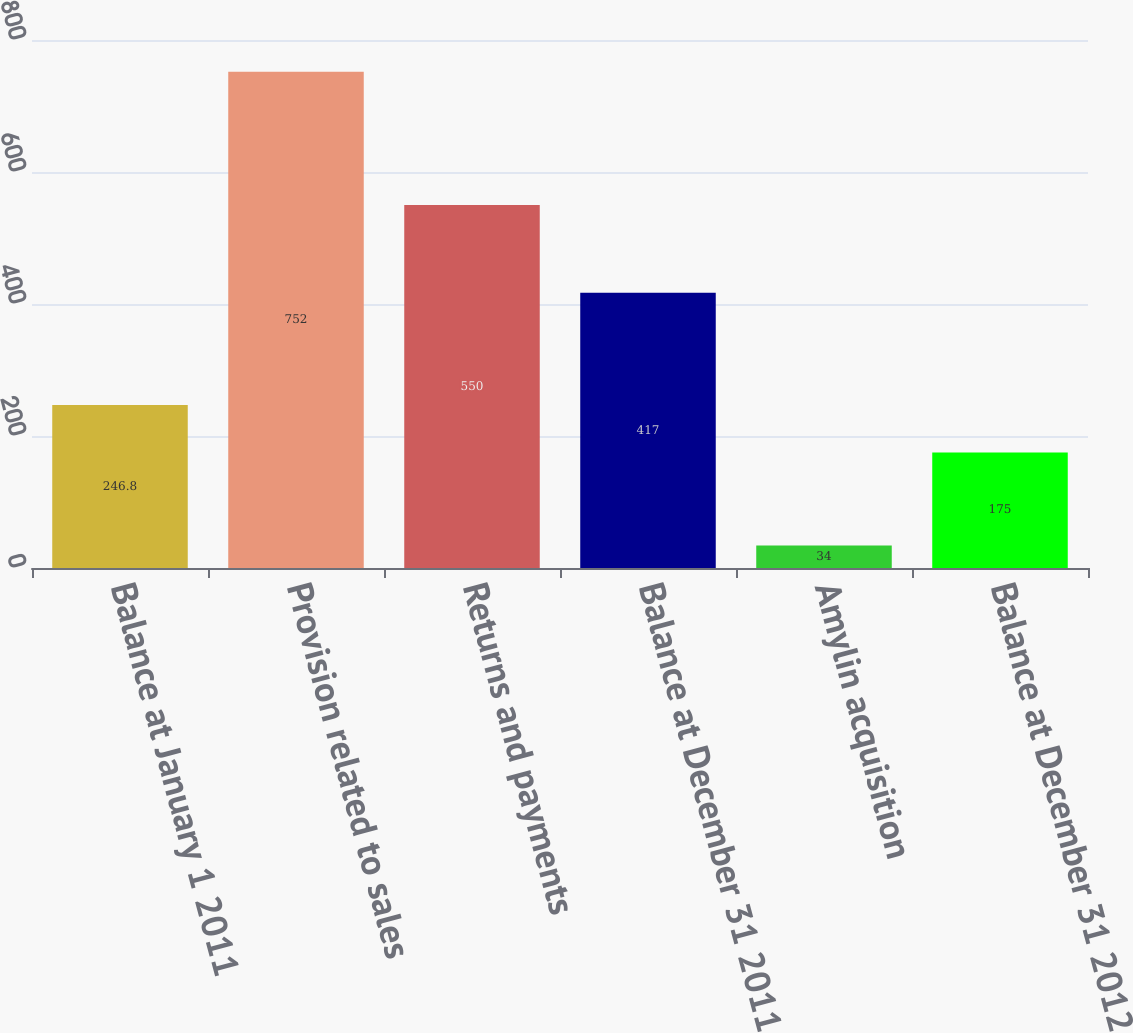Convert chart to OTSL. <chart><loc_0><loc_0><loc_500><loc_500><bar_chart><fcel>Balance at January 1 2011<fcel>Provision related to sales<fcel>Returns and payments<fcel>Balance at December 31 2011<fcel>Amylin acquisition<fcel>Balance at December 31 2012<nl><fcel>246.8<fcel>752<fcel>550<fcel>417<fcel>34<fcel>175<nl></chart> 